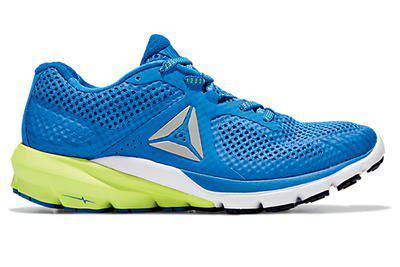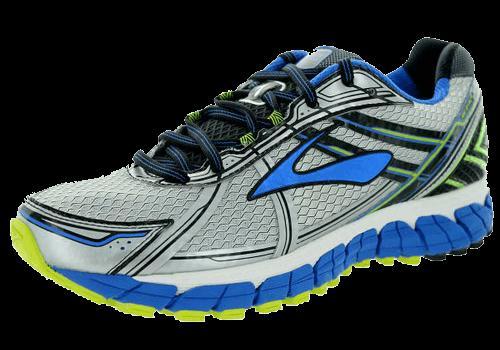The first image is the image on the left, the second image is the image on the right. Evaluate the accuracy of this statement regarding the images: "there is only one shoe on the right image on a white background". Is it true? Answer yes or no. No. 